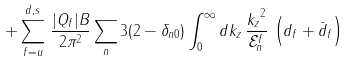<formula> <loc_0><loc_0><loc_500><loc_500>+ \sum _ { f = u } ^ { d , s } \, { \frac { | Q _ { f } | B } { 2 \pi ^ { 2 } } } \sum _ { n } 3 ( 2 - \delta _ { n 0 } ) \int _ { 0 } ^ { \infty } d k _ { z } \, { \frac { { k _ { z } } ^ { 2 } } { \mathcal { E } ^ { f } _ { n } } } \, \left ( d _ { f } + \bar { d } _ { f } \right )</formula> 